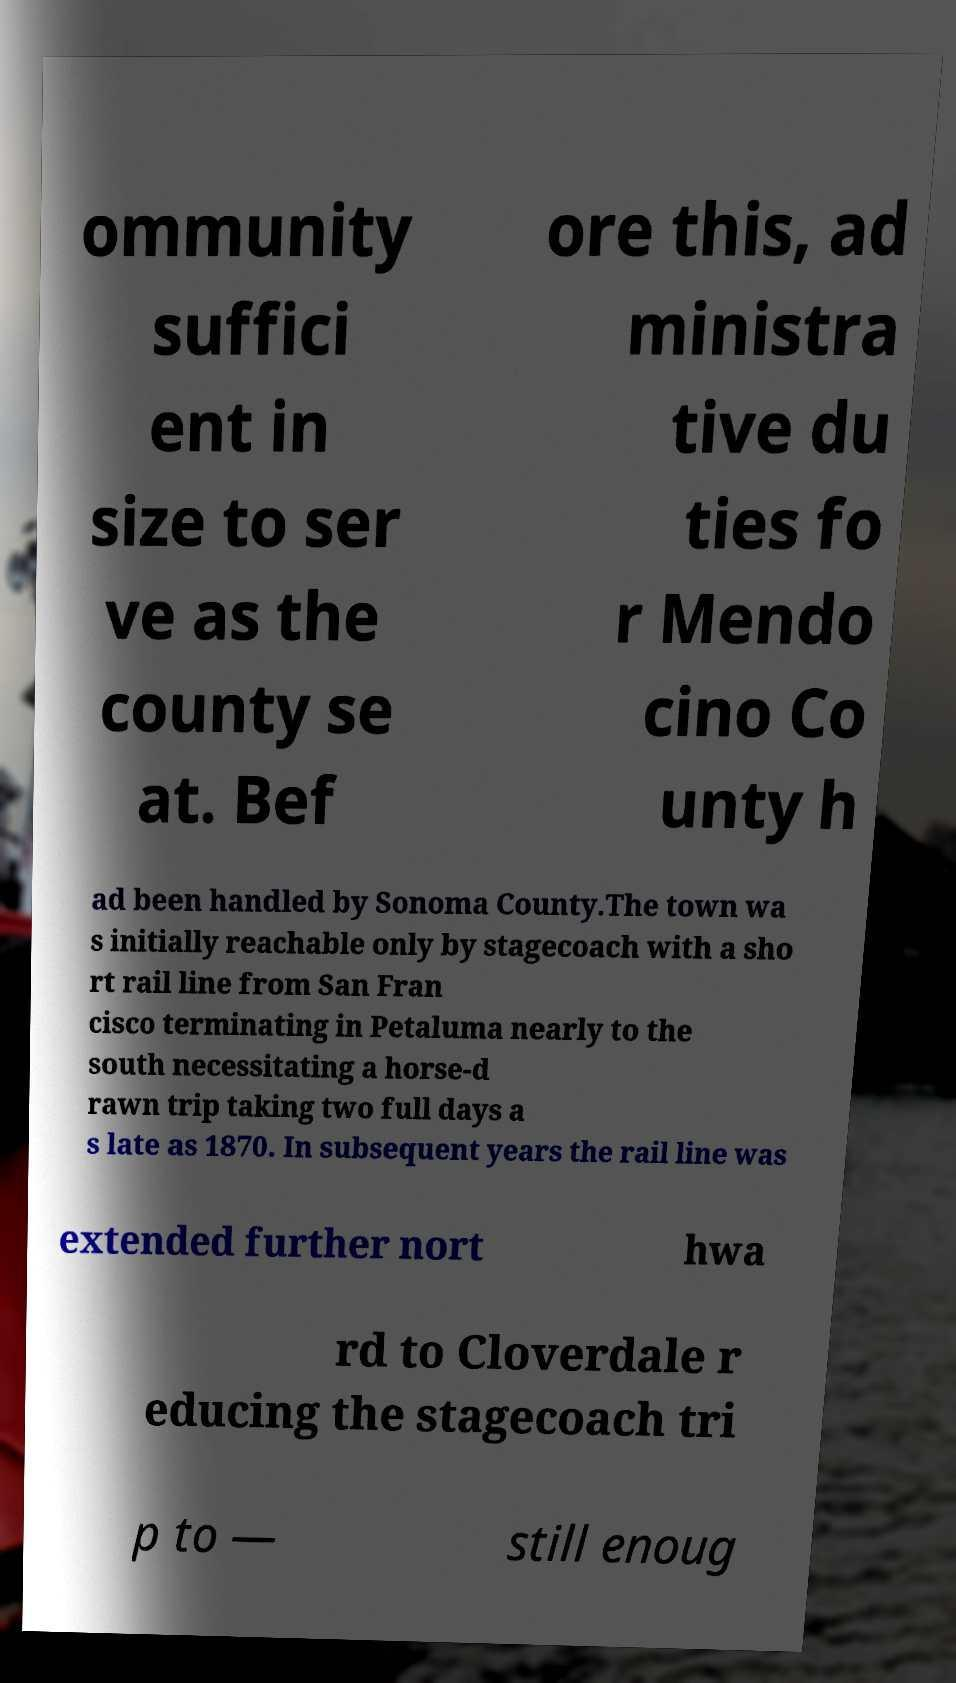Please identify and transcribe the text found in this image. ommunity suffici ent in size to ser ve as the county se at. Bef ore this, ad ministra tive du ties fo r Mendo cino Co unty h ad been handled by Sonoma County.The town wa s initially reachable only by stagecoach with a sho rt rail line from San Fran cisco terminating in Petaluma nearly to the south necessitating a horse-d rawn trip taking two full days a s late as 1870. In subsequent years the rail line was extended further nort hwa rd to Cloverdale r educing the stagecoach tri p to — still enoug 